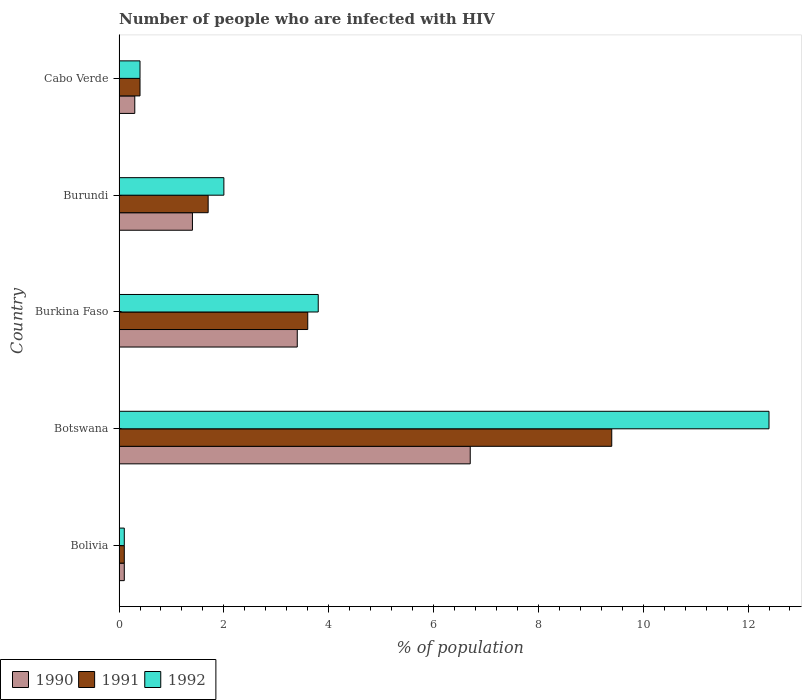Are the number of bars on each tick of the Y-axis equal?
Provide a succinct answer. Yes. How many bars are there on the 1st tick from the bottom?
Offer a very short reply. 3. What is the label of the 1st group of bars from the top?
Offer a very short reply. Cabo Verde. Across all countries, what is the minimum percentage of HIV infected population in in 1990?
Ensure brevity in your answer.  0.1. In which country was the percentage of HIV infected population in in 1991 maximum?
Your response must be concise. Botswana. In which country was the percentage of HIV infected population in in 1990 minimum?
Your answer should be compact. Bolivia. What is the total percentage of HIV infected population in in 1992 in the graph?
Give a very brief answer. 18.7. What is the average percentage of HIV infected population in in 1990 per country?
Your answer should be very brief. 2.38. Is the percentage of HIV infected population in in 1992 in Bolivia less than that in Botswana?
Your response must be concise. Yes. Is the difference between the percentage of HIV infected population in in 1991 in Bolivia and Cabo Verde greater than the difference between the percentage of HIV infected population in in 1990 in Bolivia and Cabo Verde?
Your response must be concise. No. What is the difference between the highest and the second highest percentage of HIV infected population in in 1992?
Give a very brief answer. 8.6. What is the difference between the highest and the lowest percentage of HIV infected population in in 1992?
Make the answer very short. 12.3. Is the sum of the percentage of HIV infected population in in 1992 in Bolivia and Cabo Verde greater than the maximum percentage of HIV infected population in in 1991 across all countries?
Your response must be concise. No. What does the 1st bar from the top in Botswana represents?
Your answer should be very brief. 1992. What does the 3rd bar from the bottom in Botswana represents?
Offer a terse response. 1992. Is it the case that in every country, the sum of the percentage of HIV infected population in in 1992 and percentage of HIV infected population in in 1991 is greater than the percentage of HIV infected population in in 1990?
Your answer should be compact. Yes. How many countries are there in the graph?
Provide a short and direct response. 5. What is the difference between two consecutive major ticks on the X-axis?
Offer a terse response. 2. Are the values on the major ticks of X-axis written in scientific E-notation?
Give a very brief answer. No. Does the graph contain any zero values?
Your answer should be very brief. No. Does the graph contain grids?
Offer a terse response. No. Where does the legend appear in the graph?
Offer a very short reply. Bottom left. How many legend labels are there?
Your answer should be compact. 3. What is the title of the graph?
Your answer should be compact. Number of people who are infected with HIV. What is the label or title of the X-axis?
Offer a very short reply. % of population. What is the % of population of 1991 in Bolivia?
Your answer should be very brief. 0.1. What is the % of population of 1992 in Bolivia?
Make the answer very short. 0.1. What is the % of population in 1990 in Botswana?
Give a very brief answer. 6.7. What is the % of population of 1992 in Burkina Faso?
Your answer should be compact. 3.8. What is the % of population of 1990 in Burundi?
Make the answer very short. 1.4. What is the % of population in 1992 in Burundi?
Offer a terse response. 2. What is the % of population in 1990 in Cabo Verde?
Offer a very short reply. 0.3. Across all countries, what is the maximum % of population in 1992?
Ensure brevity in your answer.  12.4. Across all countries, what is the minimum % of population in 1991?
Offer a terse response. 0.1. What is the total % of population in 1991 in the graph?
Your answer should be very brief. 15.2. What is the total % of population of 1992 in the graph?
Your answer should be compact. 18.7. What is the difference between the % of population in 1990 in Bolivia and that in Botswana?
Keep it short and to the point. -6.6. What is the difference between the % of population in 1991 in Bolivia and that in Botswana?
Make the answer very short. -9.3. What is the difference between the % of population in 1992 in Bolivia and that in Botswana?
Your answer should be very brief. -12.3. What is the difference between the % of population of 1990 in Bolivia and that in Burkina Faso?
Provide a succinct answer. -3.3. What is the difference between the % of population in 1990 in Bolivia and that in Cabo Verde?
Offer a very short reply. -0.2. What is the difference between the % of population of 1990 in Botswana and that in Burkina Faso?
Ensure brevity in your answer.  3.3. What is the difference between the % of population of 1992 in Botswana and that in Burkina Faso?
Keep it short and to the point. 8.6. What is the difference between the % of population in 1990 in Botswana and that in Burundi?
Provide a succinct answer. 5.3. What is the difference between the % of population of 1990 in Burkina Faso and that in Burundi?
Provide a short and direct response. 2. What is the difference between the % of population of 1991 in Burkina Faso and that in Burundi?
Keep it short and to the point. 1.9. What is the difference between the % of population in 1992 in Burkina Faso and that in Cabo Verde?
Offer a terse response. 3.4. What is the difference between the % of population in 1991 in Burundi and that in Cabo Verde?
Offer a terse response. 1.3. What is the difference between the % of population of 1992 in Burundi and that in Cabo Verde?
Keep it short and to the point. 1.6. What is the difference between the % of population of 1990 in Bolivia and the % of population of 1991 in Botswana?
Your response must be concise. -9.3. What is the difference between the % of population in 1990 in Bolivia and the % of population in 1992 in Botswana?
Keep it short and to the point. -12.3. What is the difference between the % of population in 1991 in Bolivia and the % of population in 1992 in Botswana?
Offer a very short reply. -12.3. What is the difference between the % of population in 1990 in Bolivia and the % of population in 1991 in Burkina Faso?
Give a very brief answer. -3.5. What is the difference between the % of population of 1990 in Bolivia and the % of population of 1991 in Burundi?
Give a very brief answer. -1.6. What is the difference between the % of population in 1990 in Bolivia and the % of population in 1992 in Burundi?
Provide a short and direct response. -1.9. What is the difference between the % of population of 1991 in Bolivia and the % of population of 1992 in Burundi?
Make the answer very short. -1.9. What is the difference between the % of population of 1990 in Bolivia and the % of population of 1992 in Cabo Verde?
Give a very brief answer. -0.3. What is the difference between the % of population of 1990 in Botswana and the % of population of 1991 in Burkina Faso?
Make the answer very short. 3.1. What is the difference between the % of population of 1990 in Botswana and the % of population of 1992 in Burkina Faso?
Offer a terse response. 2.9. What is the difference between the % of population in 1991 in Botswana and the % of population in 1992 in Burkina Faso?
Give a very brief answer. 5.6. What is the difference between the % of population in 1990 in Botswana and the % of population in 1991 in Burundi?
Your answer should be very brief. 5. What is the difference between the % of population of 1990 in Botswana and the % of population of 1992 in Burundi?
Your response must be concise. 4.7. What is the difference between the % of population in 1990 in Botswana and the % of population in 1991 in Cabo Verde?
Ensure brevity in your answer.  6.3. What is the difference between the % of population in 1990 in Botswana and the % of population in 1992 in Cabo Verde?
Offer a terse response. 6.3. What is the difference between the % of population in 1991 in Botswana and the % of population in 1992 in Cabo Verde?
Give a very brief answer. 9. What is the difference between the % of population of 1990 in Burkina Faso and the % of population of 1991 in Burundi?
Give a very brief answer. 1.7. What is the difference between the % of population in 1991 in Burkina Faso and the % of population in 1992 in Burundi?
Provide a short and direct response. 1.6. What is the difference between the % of population in 1991 in Burkina Faso and the % of population in 1992 in Cabo Verde?
Make the answer very short. 3.2. What is the difference between the % of population of 1990 in Burundi and the % of population of 1991 in Cabo Verde?
Your answer should be very brief. 1. What is the difference between the % of population of 1990 in Burundi and the % of population of 1992 in Cabo Verde?
Make the answer very short. 1. What is the difference between the % of population of 1991 in Burundi and the % of population of 1992 in Cabo Verde?
Provide a short and direct response. 1.3. What is the average % of population in 1990 per country?
Ensure brevity in your answer.  2.38. What is the average % of population of 1991 per country?
Provide a short and direct response. 3.04. What is the average % of population in 1992 per country?
Your answer should be compact. 3.74. What is the difference between the % of population of 1990 and % of population of 1992 in Bolivia?
Make the answer very short. 0. What is the difference between the % of population in 1990 and % of population in 1991 in Botswana?
Keep it short and to the point. -2.7. What is the difference between the % of population of 1990 and % of population of 1992 in Botswana?
Ensure brevity in your answer.  -5.7. What is the difference between the % of population in 1990 and % of population in 1992 in Burkina Faso?
Make the answer very short. -0.4. What is the difference between the % of population in 1991 and % of population in 1992 in Burkina Faso?
Give a very brief answer. -0.2. What is the difference between the % of population of 1990 and % of population of 1991 in Burundi?
Your response must be concise. -0.3. What is the difference between the % of population in 1990 and % of population in 1991 in Cabo Verde?
Give a very brief answer. -0.1. What is the difference between the % of population of 1991 and % of population of 1992 in Cabo Verde?
Provide a succinct answer. 0. What is the ratio of the % of population in 1990 in Bolivia to that in Botswana?
Keep it short and to the point. 0.01. What is the ratio of the % of population in 1991 in Bolivia to that in Botswana?
Your response must be concise. 0.01. What is the ratio of the % of population in 1992 in Bolivia to that in Botswana?
Offer a very short reply. 0.01. What is the ratio of the % of population of 1990 in Bolivia to that in Burkina Faso?
Your answer should be very brief. 0.03. What is the ratio of the % of population in 1991 in Bolivia to that in Burkina Faso?
Provide a succinct answer. 0.03. What is the ratio of the % of population in 1992 in Bolivia to that in Burkina Faso?
Provide a short and direct response. 0.03. What is the ratio of the % of population of 1990 in Bolivia to that in Burundi?
Provide a short and direct response. 0.07. What is the ratio of the % of population of 1991 in Bolivia to that in Burundi?
Offer a terse response. 0.06. What is the ratio of the % of population in 1990 in Bolivia to that in Cabo Verde?
Keep it short and to the point. 0.33. What is the ratio of the % of population in 1990 in Botswana to that in Burkina Faso?
Your answer should be compact. 1.97. What is the ratio of the % of population of 1991 in Botswana to that in Burkina Faso?
Your response must be concise. 2.61. What is the ratio of the % of population of 1992 in Botswana to that in Burkina Faso?
Provide a short and direct response. 3.26. What is the ratio of the % of population in 1990 in Botswana to that in Burundi?
Your response must be concise. 4.79. What is the ratio of the % of population in 1991 in Botswana to that in Burundi?
Keep it short and to the point. 5.53. What is the ratio of the % of population of 1990 in Botswana to that in Cabo Verde?
Your response must be concise. 22.33. What is the ratio of the % of population of 1991 in Botswana to that in Cabo Verde?
Your answer should be very brief. 23.5. What is the ratio of the % of population in 1990 in Burkina Faso to that in Burundi?
Give a very brief answer. 2.43. What is the ratio of the % of population of 1991 in Burkina Faso to that in Burundi?
Make the answer very short. 2.12. What is the ratio of the % of population in 1992 in Burkina Faso to that in Burundi?
Provide a succinct answer. 1.9. What is the ratio of the % of population in 1990 in Burkina Faso to that in Cabo Verde?
Make the answer very short. 11.33. What is the ratio of the % of population of 1991 in Burkina Faso to that in Cabo Verde?
Offer a very short reply. 9. What is the ratio of the % of population in 1990 in Burundi to that in Cabo Verde?
Give a very brief answer. 4.67. What is the ratio of the % of population in 1991 in Burundi to that in Cabo Verde?
Offer a terse response. 4.25. What is the difference between the highest and the second highest % of population of 1990?
Give a very brief answer. 3.3. What is the difference between the highest and the second highest % of population of 1991?
Provide a short and direct response. 5.8. What is the difference between the highest and the lowest % of population of 1992?
Offer a terse response. 12.3. 